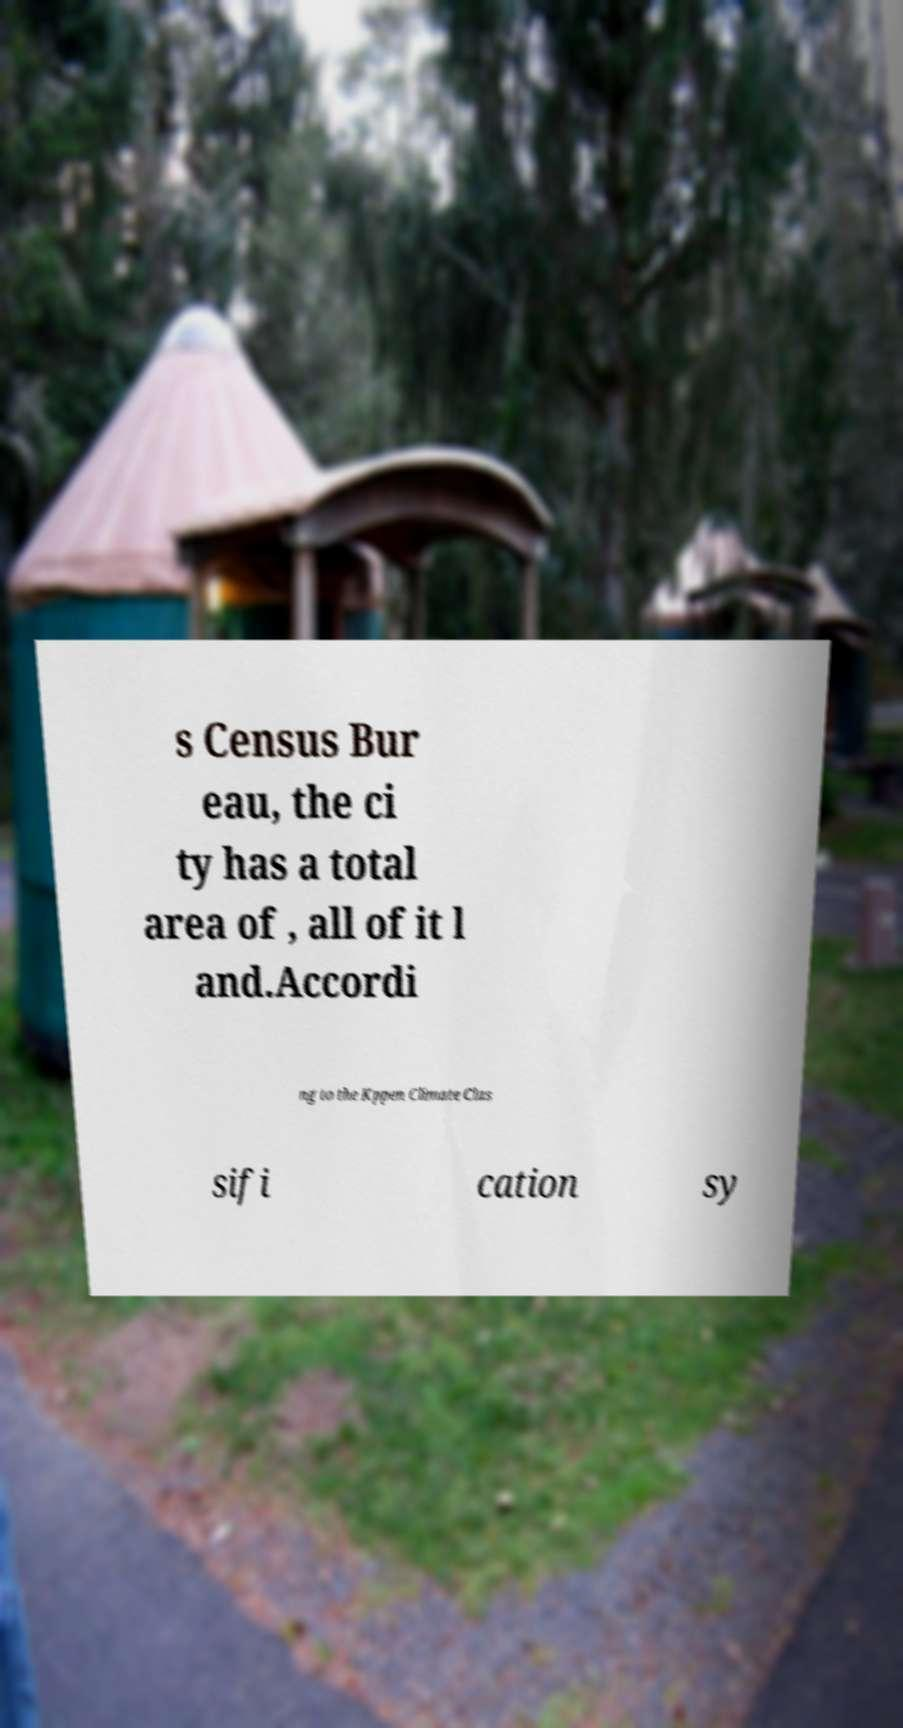There's text embedded in this image that I need extracted. Can you transcribe it verbatim? s Census Bur eau, the ci ty has a total area of , all of it l and.Accordi ng to the Kppen Climate Clas sifi cation sy 